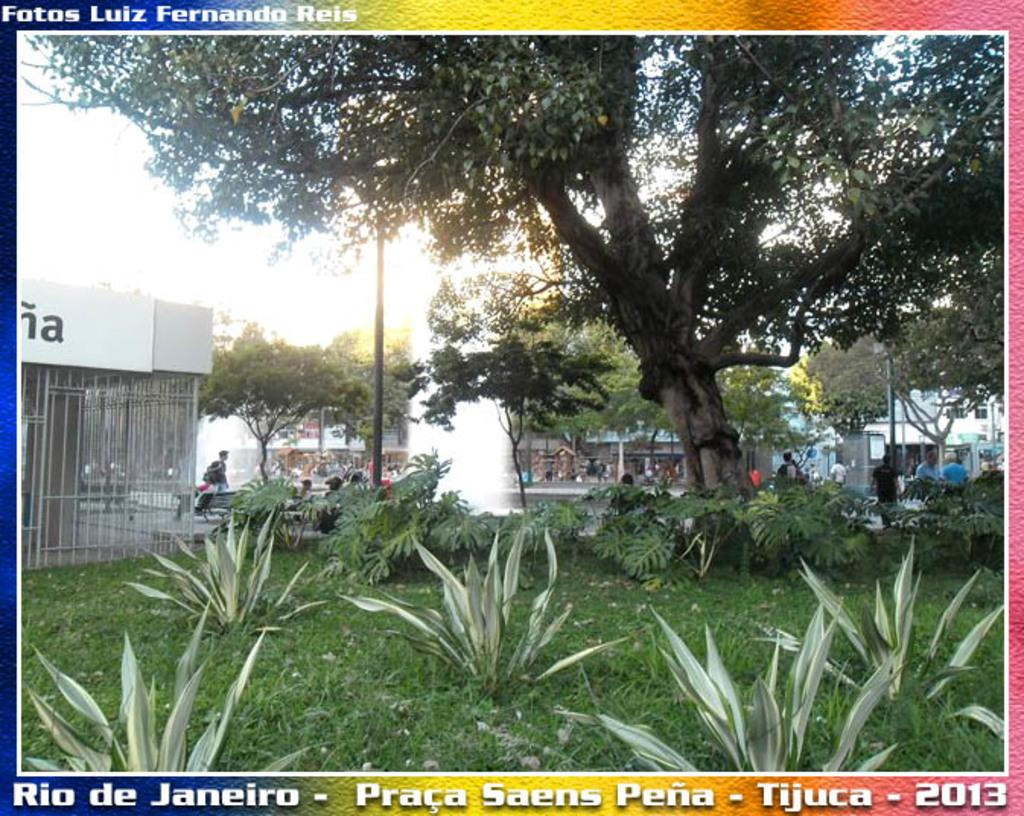What type of vegetation is present at the bottom of the image? There are plants and grass at the bottom of the image. What can be found in the center of the image? There are people and a fountain in the center of the image. What is located at the top of the image? There is a tree at the top of the image. What type of structure is visible towards the left side of the image? There is a building towards the left side of the image. How many fish are swimming in the bucket in the image? There is no bucket or fish present in the image. What type of mathematical operation is being performed on the addition sign in the image? There is no addition sign present in the image. 